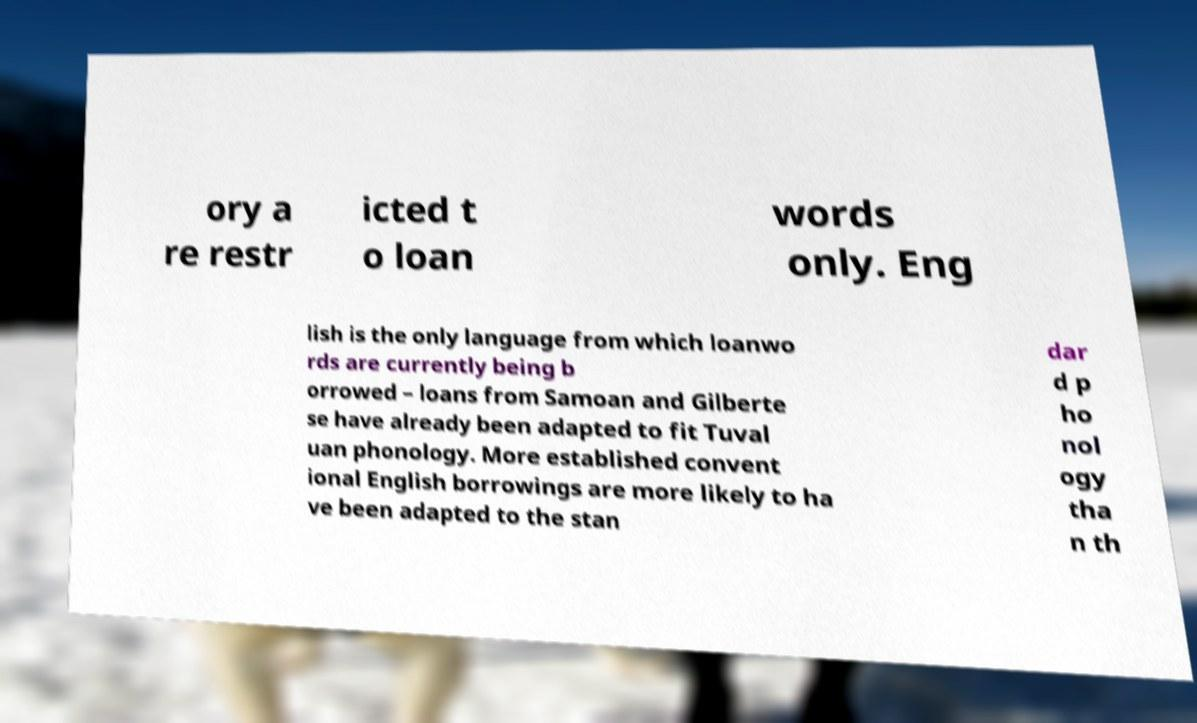Can you accurately transcribe the text from the provided image for me? ory a re restr icted t o loan words only. Eng lish is the only language from which loanwo rds are currently being b orrowed – loans from Samoan and Gilberte se have already been adapted to fit Tuval uan phonology. More established convent ional English borrowings are more likely to ha ve been adapted to the stan dar d p ho nol ogy tha n th 